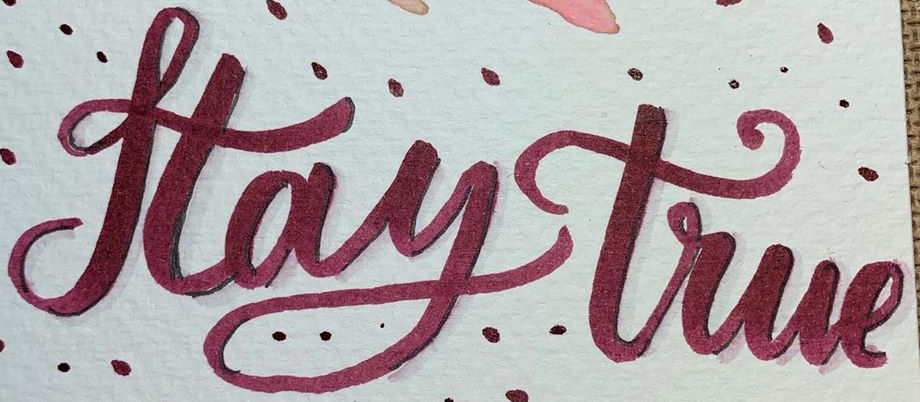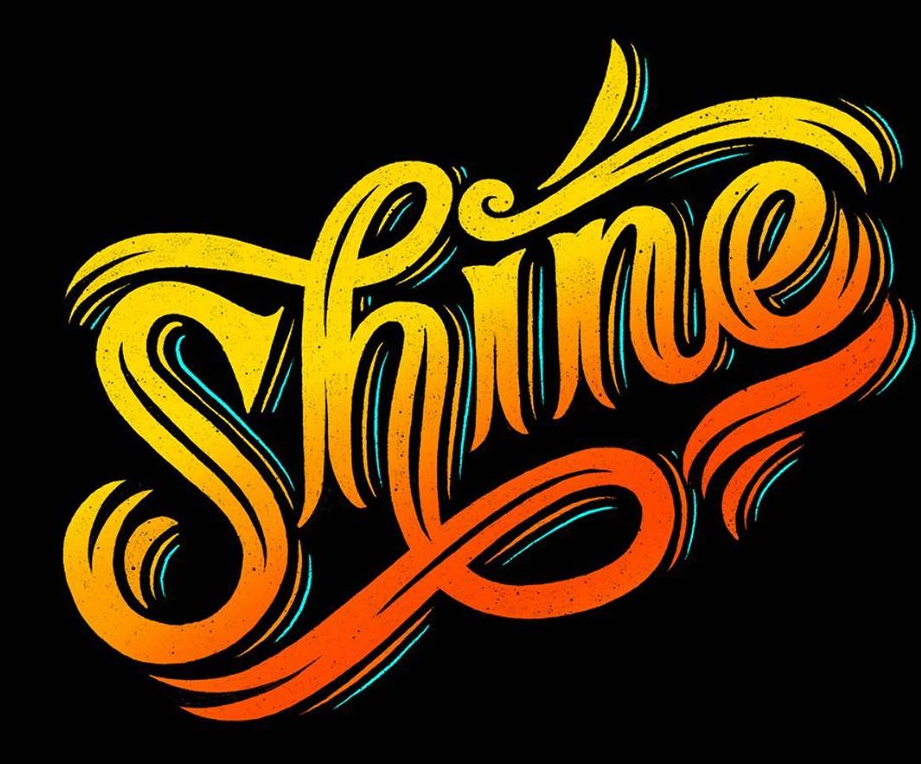What text is displayed in these images sequentially, separated by a semicolon? Haytrue; Shine 